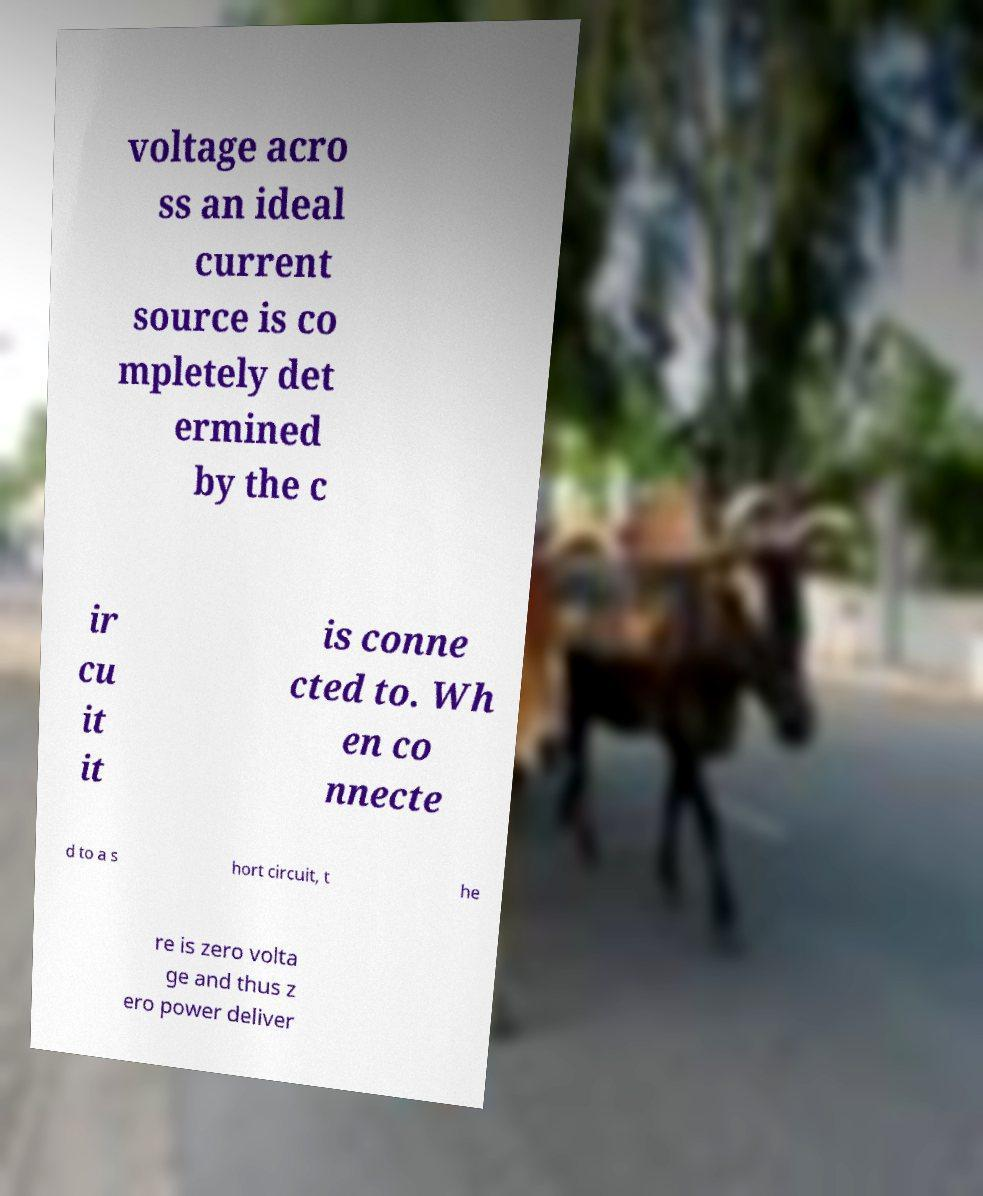Can you accurately transcribe the text from the provided image for me? voltage acro ss an ideal current source is co mpletely det ermined by the c ir cu it it is conne cted to. Wh en co nnecte d to a s hort circuit, t he re is zero volta ge and thus z ero power deliver 